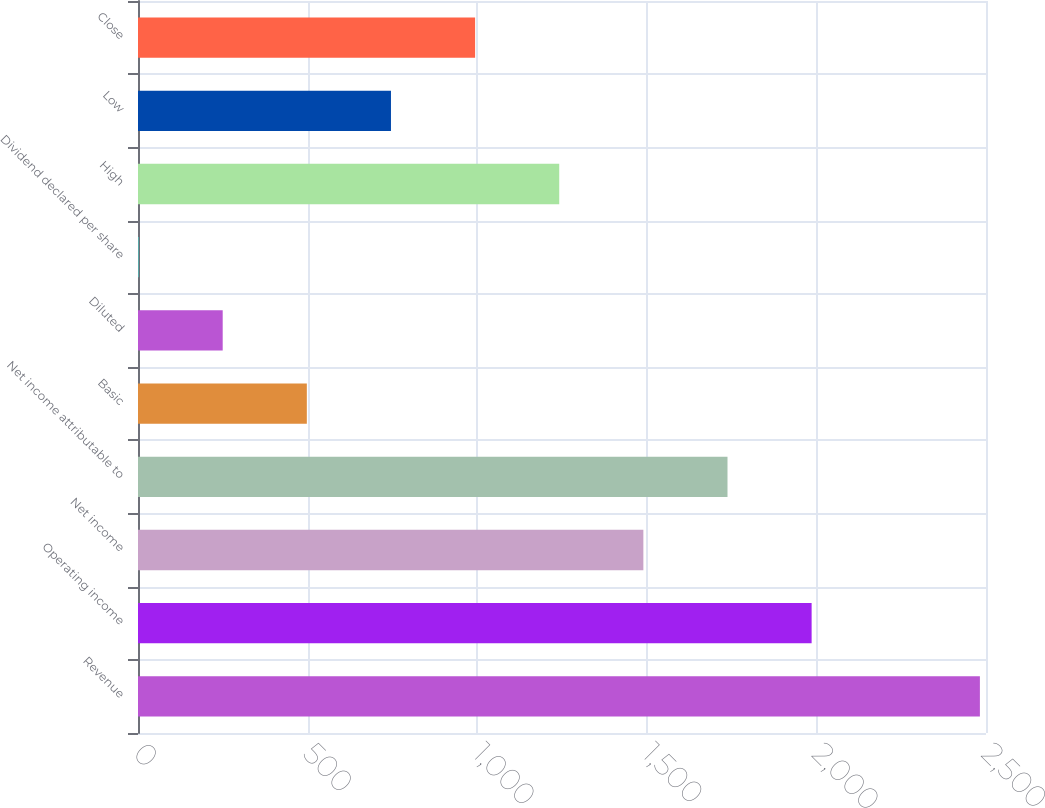Convert chart. <chart><loc_0><loc_0><loc_500><loc_500><bar_chart><fcel>Revenue<fcel>Operating income<fcel>Net income<fcel>Net income attributable to<fcel>Basic<fcel>Diluted<fcel>Dividend declared per share<fcel>High<fcel>Low<fcel>Close<nl><fcel>2482<fcel>1985.92<fcel>1489.86<fcel>1737.89<fcel>497.74<fcel>249.71<fcel>1.68<fcel>1241.83<fcel>745.77<fcel>993.8<nl></chart> 